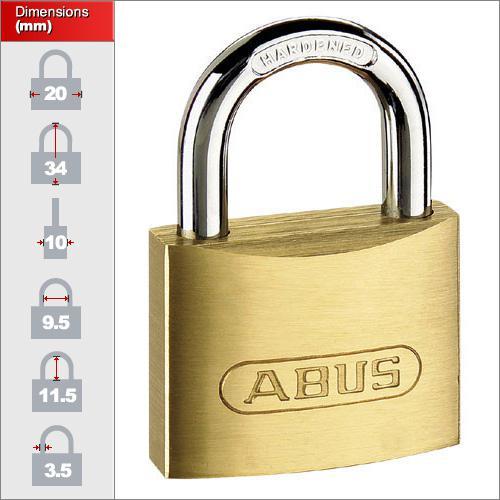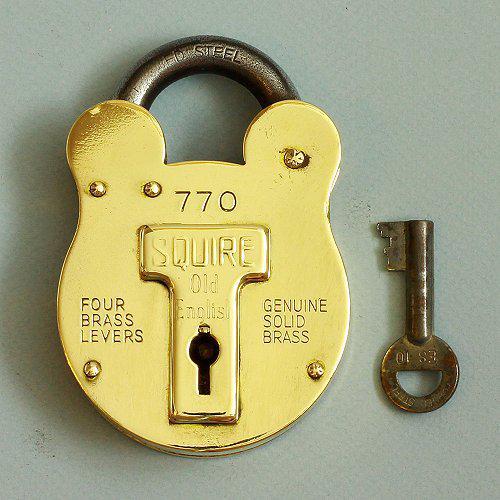The first image is the image on the left, the second image is the image on the right. For the images displayed, is the sentence "There are at least 3 keys present, next to locks." factually correct? Answer yes or no. No. The first image is the image on the left, the second image is the image on the right. For the images shown, is this caption "In one image of each pair there is a keyhole on the front of the lock." true? Answer yes or no. Yes. 